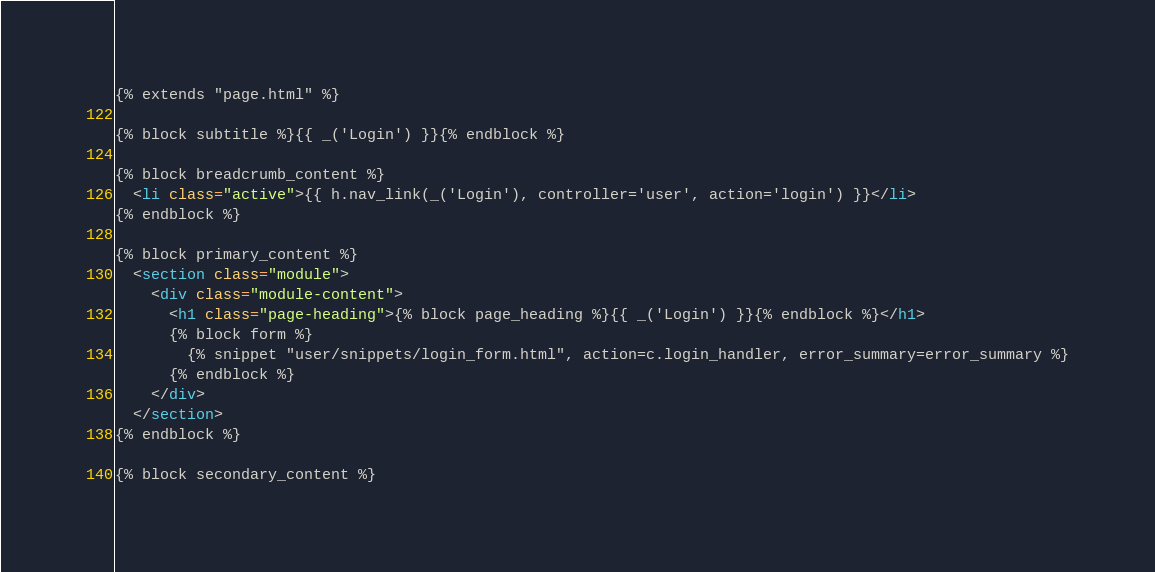Convert code to text. <code><loc_0><loc_0><loc_500><loc_500><_HTML_>{% extends "page.html" %}

{% block subtitle %}{{ _('Login') }}{% endblock %}

{% block breadcrumb_content %}
  <li class="active">{{ h.nav_link(_('Login'), controller='user', action='login') }}</li>
{% endblock %}

{% block primary_content %}
  <section class="module">
    <div class="module-content">
      <h1 class="page-heading">{% block page_heading %}{{ _('Login') }}{% endblock %}</h1>
      {% block form %}
        {% snippet "user/snippets/login_form.html", action=c.login_handler, error_summary=error_summary %}
      {% endblock %}
    </div>
  </section>
{% endblock %}

{% block secondary_content %}</code> 